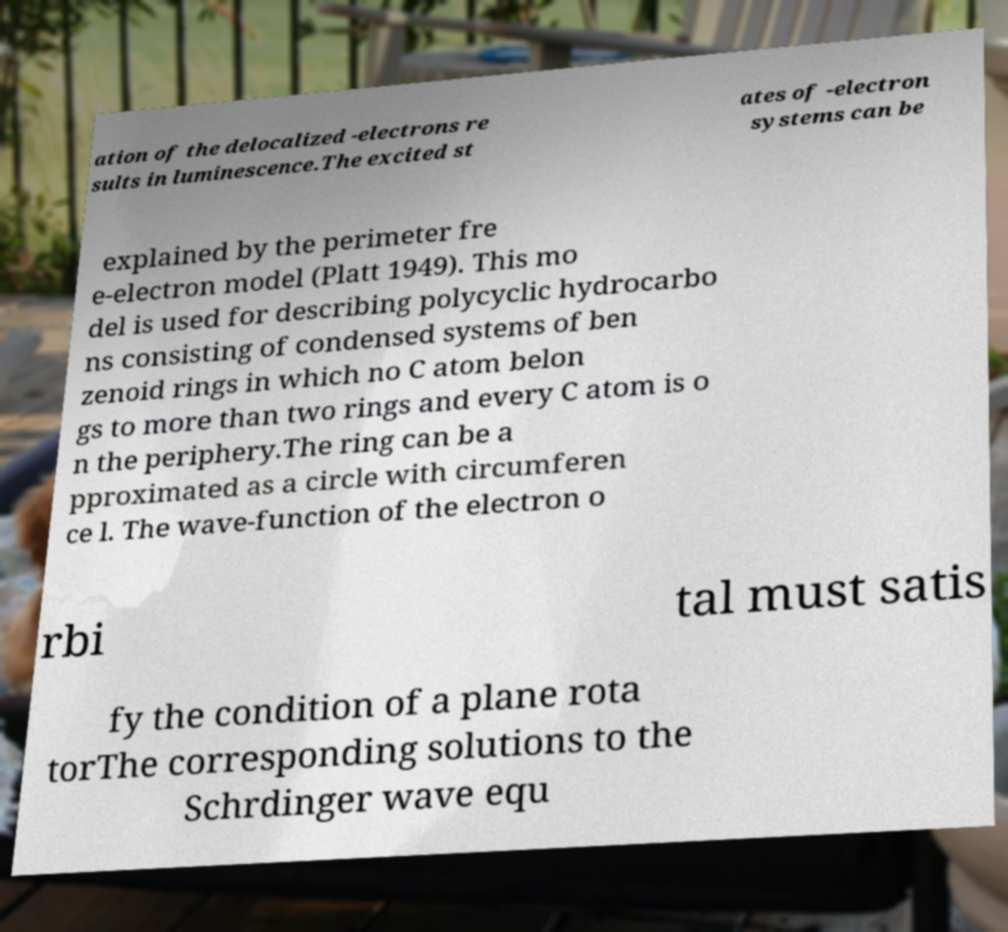I need the written content from this picture converted into text. Can you do that? ation of the delocalized -electrons re sults in luminescence.The excited st ates of -electron systems can be explained by the perimeter fre e-electron model (Platt 1949). This mo del is used for describing polycyclic hydrocarbo ns consisting of condensed systems of ben zenoid rings in which no C atom belon gs to more than two rings and every C atom is o n the periphery.The ring can be a pproximated as a circle with circumferen ce l. The wave-function of the electron o rbi tal must satis fy the condition of a plane rota torThe corresponding solutions to the Schrdinger wave equ 